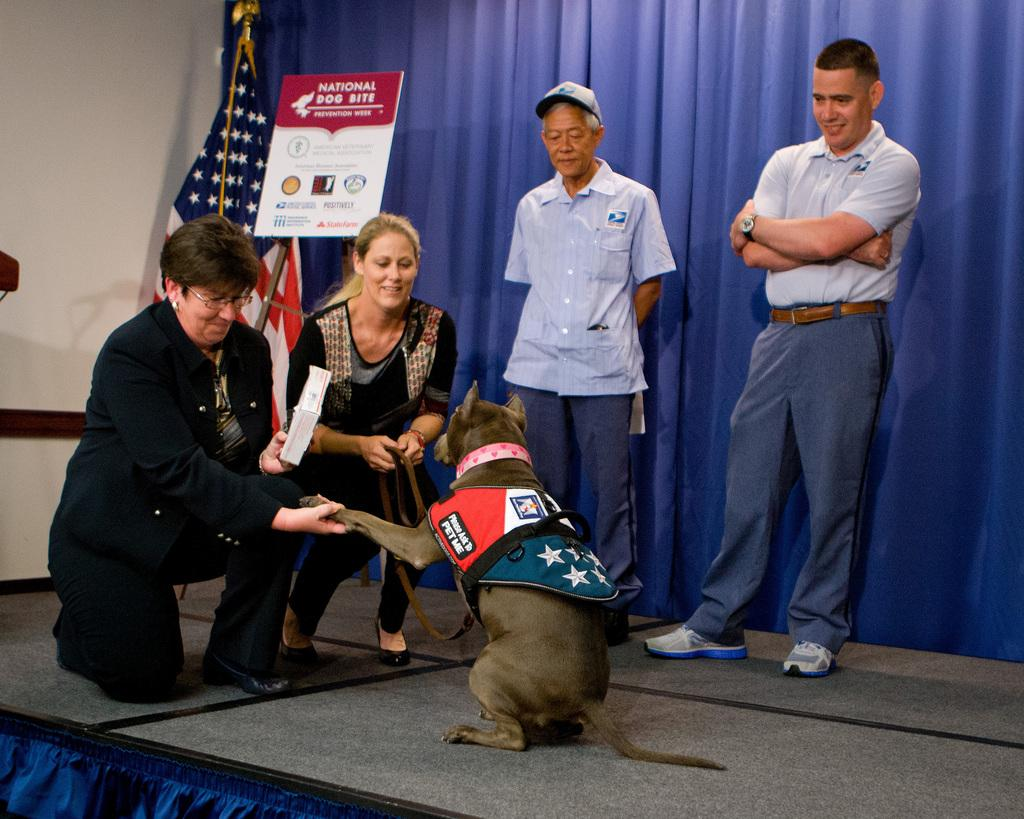What type of animal is present in the image? There is a dog in the image. How many women are in the image? There are two women in the image. How many men are in the image? There are two men in the image. Where are the people located in the image? They are all on the floor. What can be seen in the background of the image? There is a curtain, a board, a flag, and a wall in the background of the image. How many houses are visible in the image? There are no houses visible in the image. Is there a cobweb present in the image? There is no cobweb present in the image. 